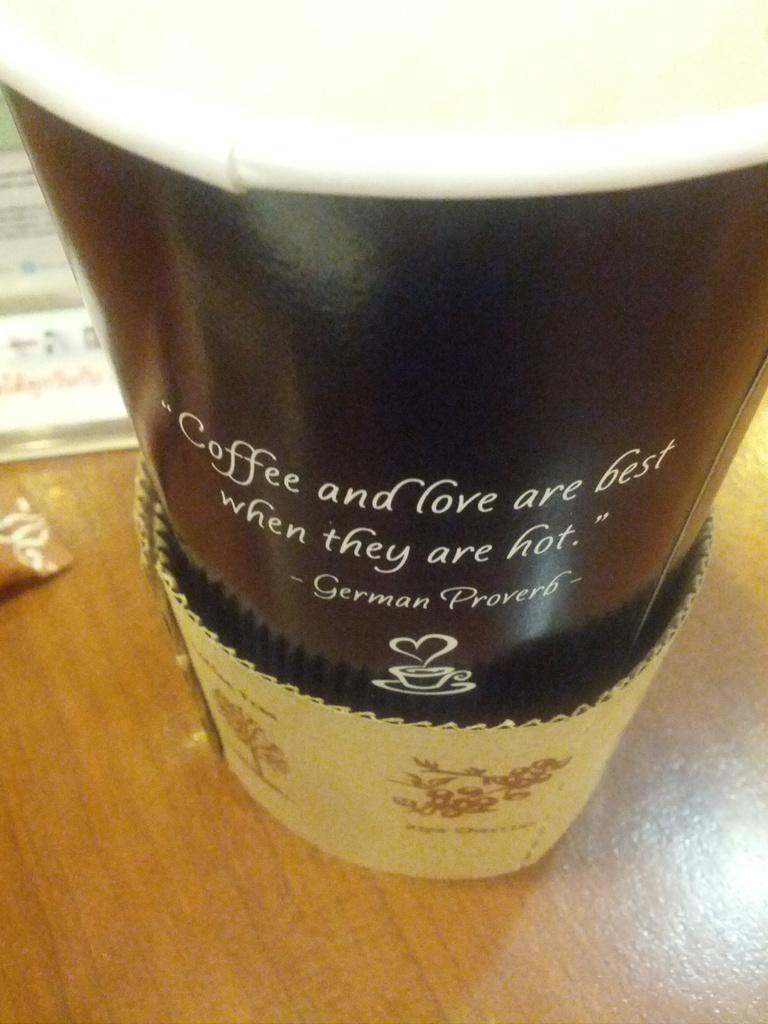What is in the cup?
Your answer should be very brief. Coffee. 